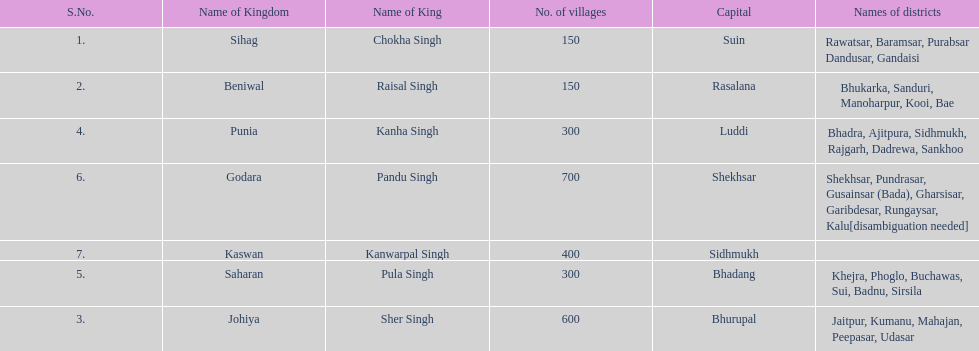Help me parse the entirety of this table. {'header': ['S.No.', 'Name of Kingdom', 'Name of King', 'No. of villages', 'Capital', 'Names of districts'], 'rows': [['1.', 'Sihag', 'Chokha Singh', '150', 'Suin', 'Rawatsar, Baramsar, Purabsar Dandusar, Gandaisi'], ['2.', 'Beniwal', 'Raisal Singh', '150', 'Rasalana', 'Bhukarka, Sanduri, Manoharpur, Kooi, Bae'], ['4.', 'Punia', 'Kanha Singh', '300', 'Luddi', 'Bhadra, Ajitpura, Sidhmukh, Rajgarh, Dadrewa, Sankhoo'], ['6.', 'Godara', 'Pandu Singh', '700', 'Shekhsar', 'Shekhsar, Pundrasar, Gusainsar (Bada), Gharsisar, Garibdesar, Rungaysar, Kalu[disambiguation needed]'], ['7.', 'Kaswan', 'Kanwarpal Singh', '400', 'Sidhmukh', ''], ['5.', 'Saharan', 'Pula Singh', '300', 'Bhadang', 'Khejra, Phoglo, Buchawas, Sui, Badnu, Sirsila'], ['3.', 'Johiya', 'Sher Singh', '600', 'Bhurupal', 'Jaitpur, Kumanu, Mahajan, Peepasar, Udasar']]} What are the number of villages johiya has according to this chart? 600. 